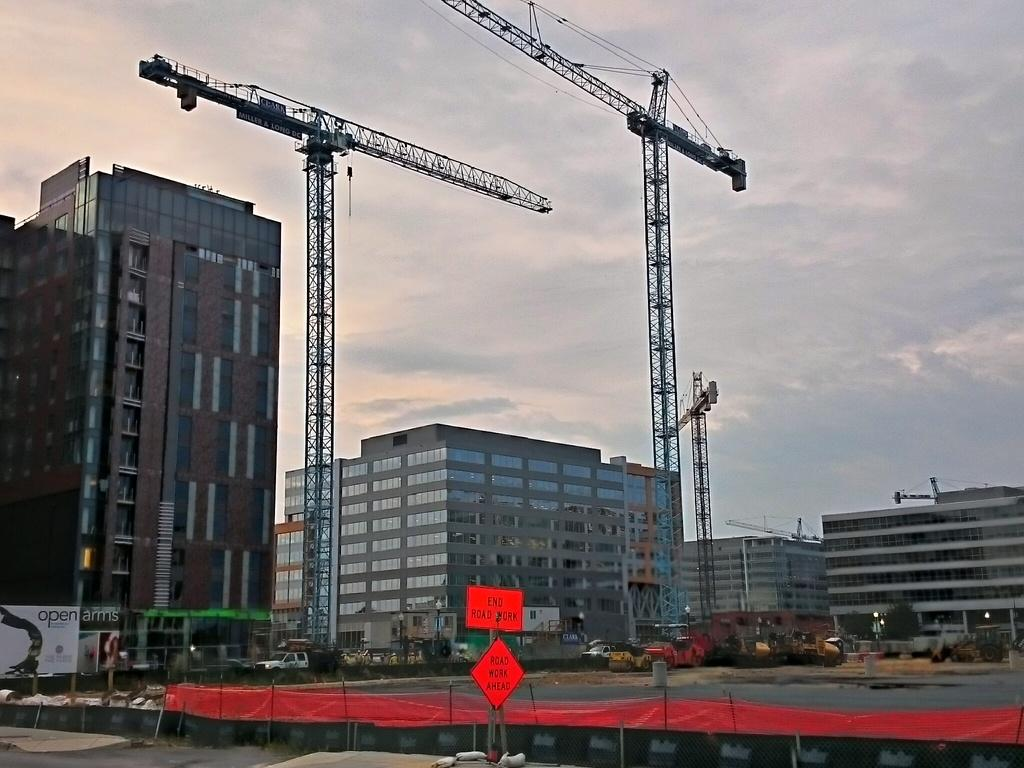What type of structures can be seen in the image? There are buildings in the image. What is visible in the sky? The sky is visible with clouds in the image. What equipment is being used for construction? Construction cranes are present in the image. What is covering something in the image? There is a polythene cover visible in the image. What type of signs are in the image? Sign boards are in the image. What mode of transportation is present? Motor vehicles are present in the image. What type of machinery is being used for construction? Excavators are visible in the image. What natural element is present in the image? Water is present in the image. What type of vegetation is in the image? Trees are in the image. What type of promotional content is in the image? There are advertisements in the image. What part of the environment is visible in the image? The ground is visible in the image. What type of jam is being spread on the hose in the image? There is no hose or jam present in the image. What type of driving is being depicted in the image? There is no driving depicted in the image. 